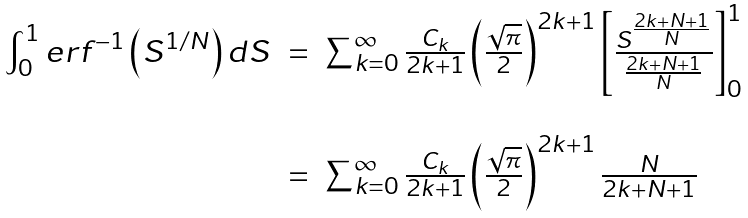Convert formula to latex. <formula><loc_0><loc_0><loc_500><loc_500>\begin{array} { l c l } \int _ { 0 } ^ { 1 } e r f ^ { - 1 } \left ( S ^ { 1 / N } \right ) { d } S & = & \sum _ { k = 0 } ^ { \infty } \frac { C _ { k } } { 2 k + 1 } \left ( \frac { \sqrt { \pi } } { 2 } \right ) ^ { 2 k + 1 } \left [ \frac { S ^ { \frac { 2 k + N + 1 } { N } } } { { \frac { 2 k + N + 1 } { N } } } \right ] _ { 0 } ^ { 1 } \ \\ \\ & = & \sum _ { k = 0 } ^ { \infty } \frac { C _ { k } } { 2 k + 1 } \left ( \frac { \sqrt { \pi } } { 2 } \right ) ^ { 2 k + 1 } \frac { N } { 2 k + N + 1 } \end{array}</formula> 